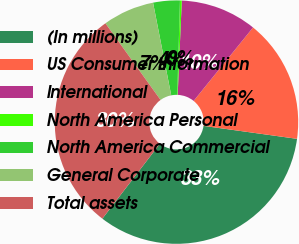<chart> <loc_0><loc_0><loc_500><loc_500><pie_chart><fcel>(In millions)<fcel>US Consumer Information<fcel>International<fcel>North America Personal<fcel>North America Commercial<fcel>General Corporate<fcel>Total assets<nl><fcel>33.23%<fcel>16.37%<fcel>10.13%<fcel>0.24%<fcel>3.54%<fcel>6.84%<fcel>29.66%<nl></chart> 